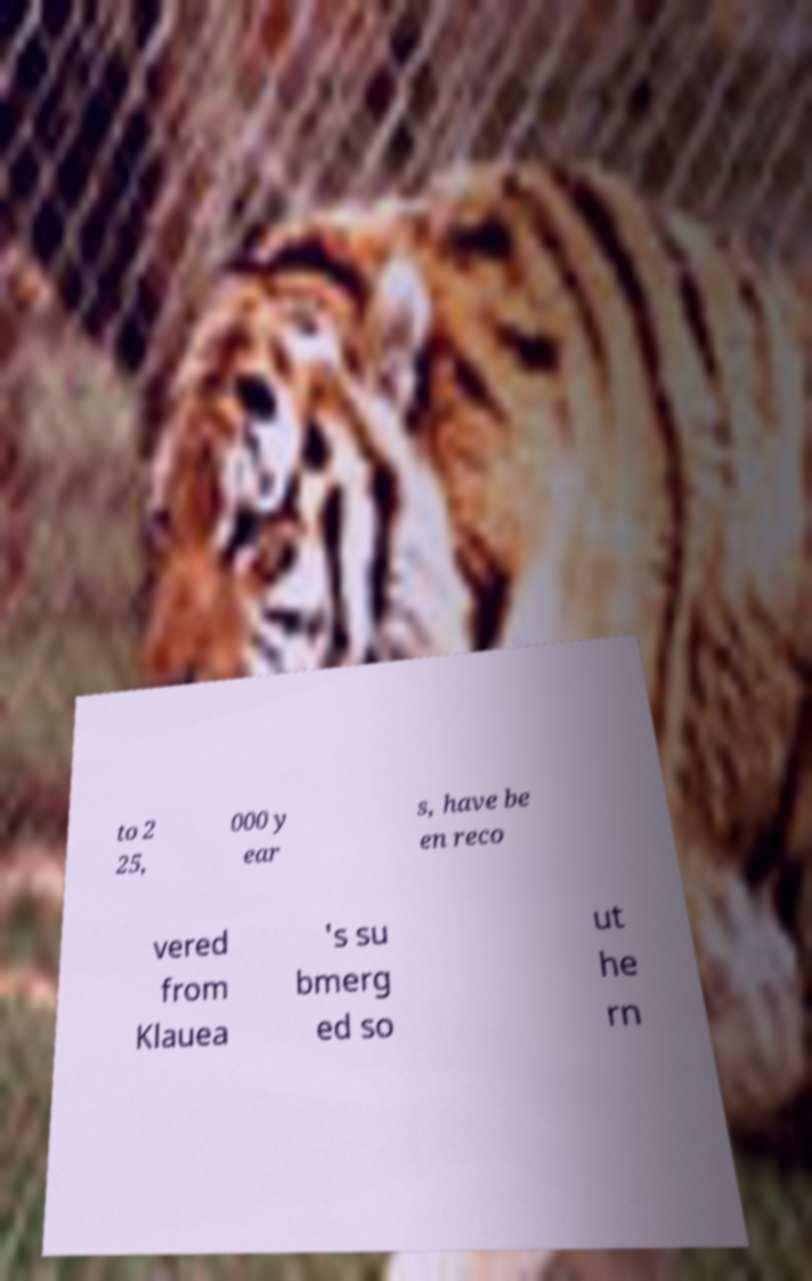Please identify and transcribe the text found in this image. to 2 25, 000 y ear s, have be en reco vered from Klauea 's su bmerg ed so ut he rn 